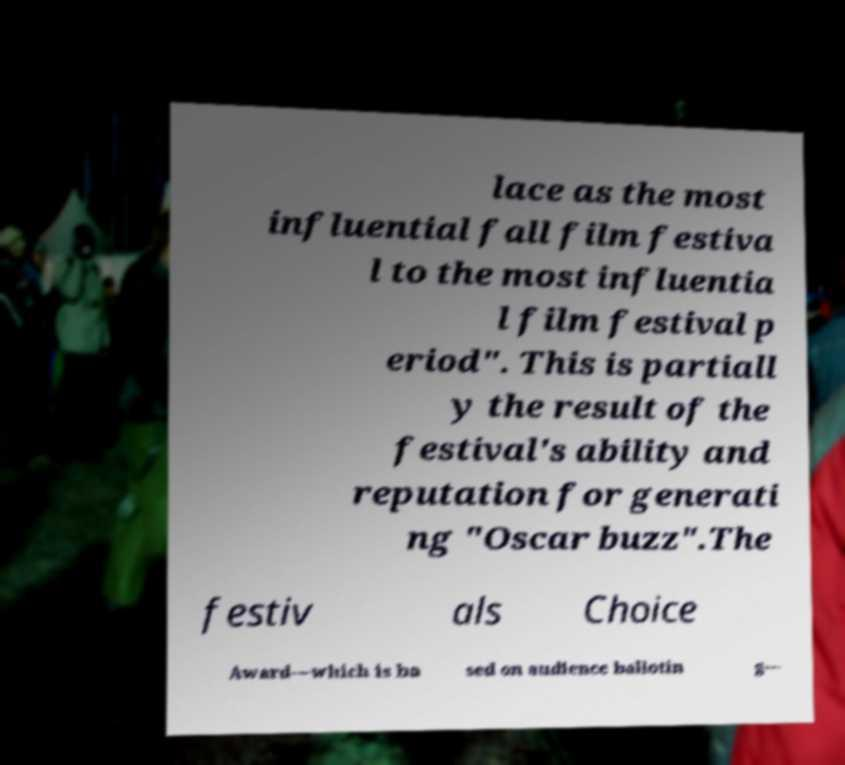For documentation purposes, I need the text within this image transcribed. Could you provide that? lace as the most influential fall film festiva l to the most influentia l film festival p eriod". This is partiall y the result of the festival's ability and reputation for generati ng "Oscar buzz".The festiv als Choice Award—which is ba sed on audience ballotin g— 